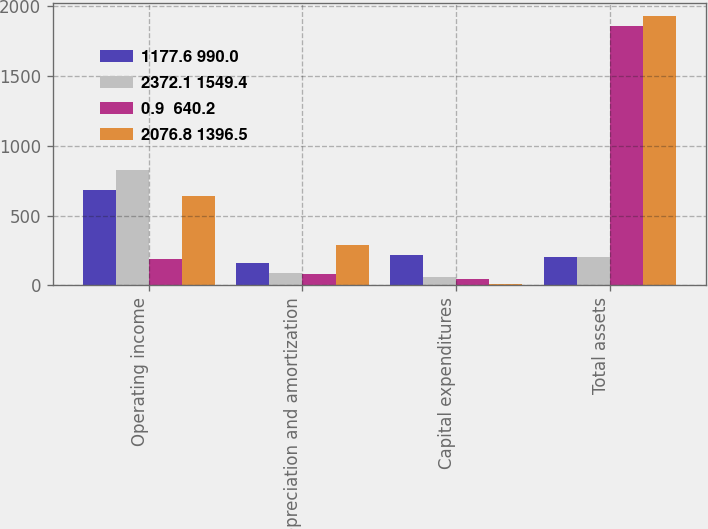<chart> <loc_0><loc_0><loc_500><loc_500><stacked_bar_chart><ecel><fcel>Operating income<fcel>Depreciation and amortization<fcel>Capital expenditures<fcel>Total assets<nl><fcel>1177.6 990.0<fcel>680.3<fcel>160.8<fcel>219.3<fcel>203.45<nl><fcel>2372.1 1549.4<fcel>822.7<fcel>85.2<fcel>61.4<fcel>203.45<nl><fcel>0.9  640.2<fcel>187.6<fcel>82.3<fcel>43.8<fcel>1857.3<nl><fcel>2076.8 1396.5<fcel>641.1<fcel>292.6<fcel>7.2<fcel>1926.4<nl></chart> 